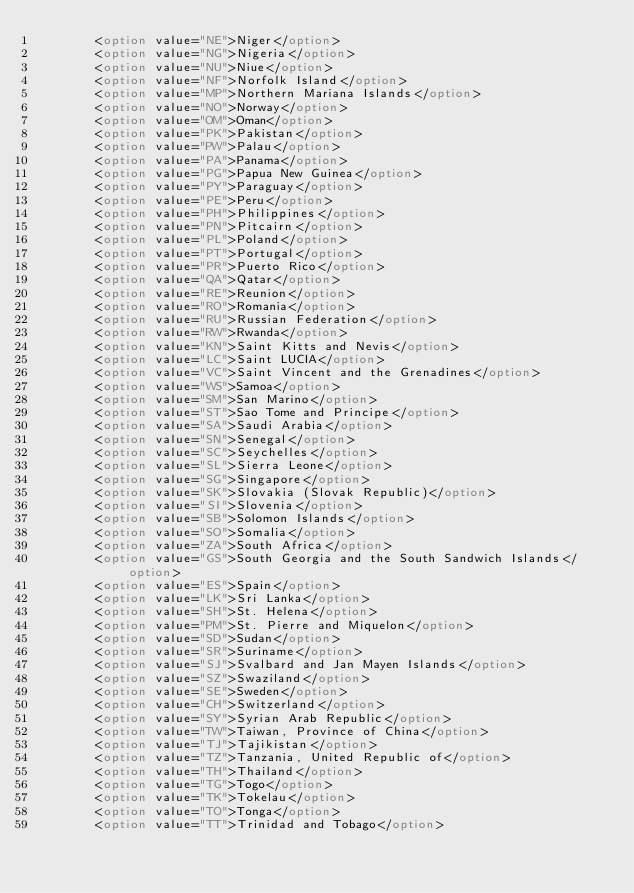<code> <loc_0><loc_0><loc_500><loc_500><_HTML_>				<option value="NE">Niger</option>
				<option value="NG">Nigeria</option>
				<option value="NU">Niue</option>
				<option value="NF">Norfolk Island</option>
				<option value="MP">Northern Mariana Islands</option>
				<option value="NO">Norway</option>
				<option value="OM">Oman</option>
				<option value="PK">Pakistan</option>
				<option value="PW">Palau</option>
				<option value="PA">Panama</option>
				<option value="PG">Papua New Guinea</option>
				<option value="PY">Paraguay</option>
				<option value="PE">Peru</option>
				<option value="PH">Philippines</option>
				<option value="PN">Pitcairn</option>
				<option value="PL">Poland</option>
				<option value="PT">Portugal</option>
				<option value="PR">Puerto Rico</option>
				<option value="QA">Qatar</option>
				<option value="RE">Reunion</option>
				<option value="RO">Romania</option>
				<option value="RU">Russian Federation</option>
				<option value="RW">Rwanda</option>
				<option value="KN">Saint Kitts and Nevis</option>
				<option value="LC">Saint LUCIA</option>
				<option value="VC">Saint Vincent and the Grenadines</option>
				<option value="WS">Samoa</option>
				<option value="SM">San Marino</option>
				<option value="ST">Sao Tome and Principe</option>
				<option value="SA">Saudi Arabia</option>
				<option value="SN">Senegal</option>
				<option value="SC">Seychelles</option>
				<option value="SL">Sierra Leone</option>
				<option value="SG">Singapore</option>
				<option value="SK">Slovakia (Slovak Republic)</option>
				<option value="SI">Slovenia</option>
				<option value="SB">Solomon Islands</option>
				<option value="SO">Somalia</option>
				<option value="ZA">South Africa</option>
				<option value="GS">South Georgia and the South Sandwich Islands</option>
				<option value="ES">Spain</option>
				<option value="LK">Sri Lanka</option>
				<option value="SH">St. Helena</option>
				<option value="PM">St. Pierre and Miquelon</option>
				<option value="SD">Sudan</option>
				<option value="SR">Suriname</option>
				<option value="SJ">Svalbard and Jan Mayen Islands</option>
				<option value="SZ">Swaziland</option>
				<option value="SE">Sweden</option>
				<option value="CH">Switzerland</option>
				<option value="SY">Syrian Arab Republic</option>
				<option value="TW">Taiwan, Province of China</option>
				<option value="TJ">Tajikistan</option>
				<option value="TZ">Tanzania, United Republic of</option>
				<option value="TH">Thailand</option>
				<option value="TG">Togo</option>
				<option value="TK">Tokelau</option>
				<option value="TO">Tonga</option>
				<option value="TT">Trinidad and Tobago</option></code> 